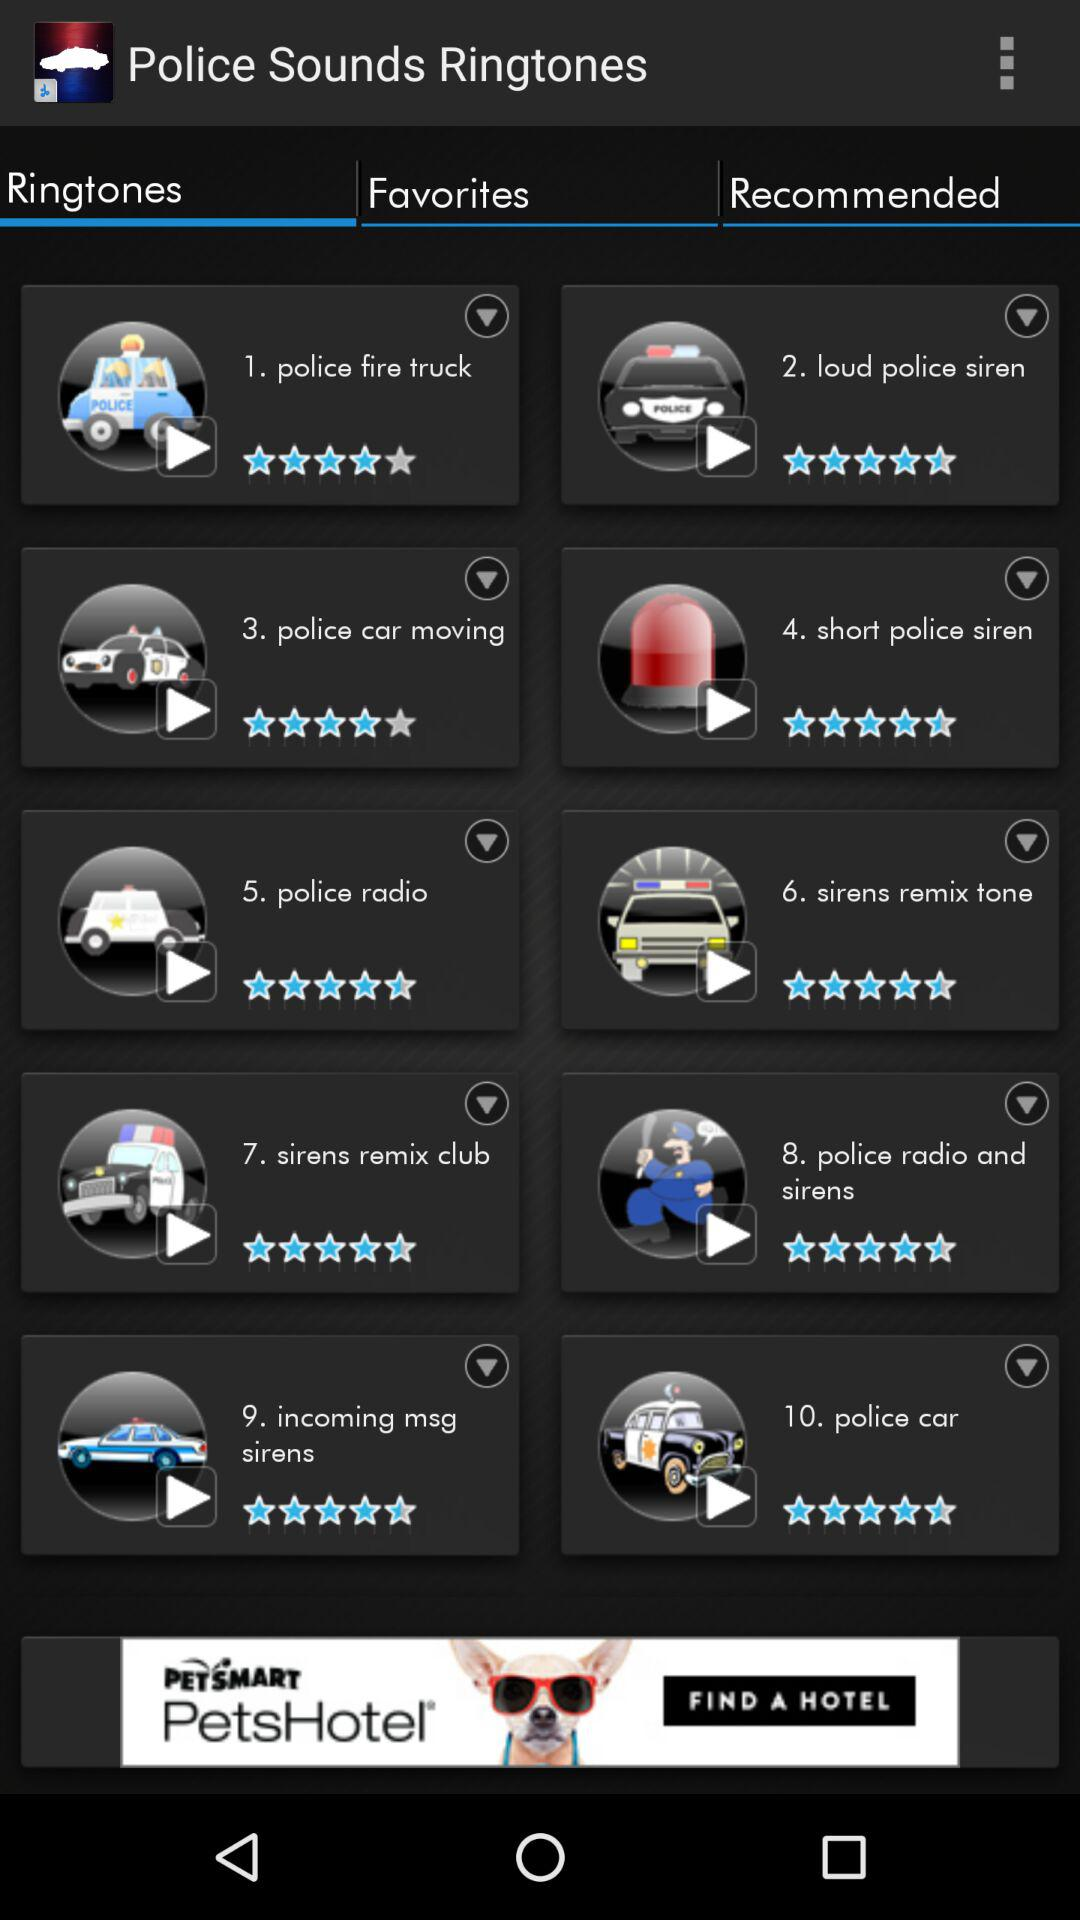What is the name of the application? The name of the application is "Police Sounds Ringtones". 